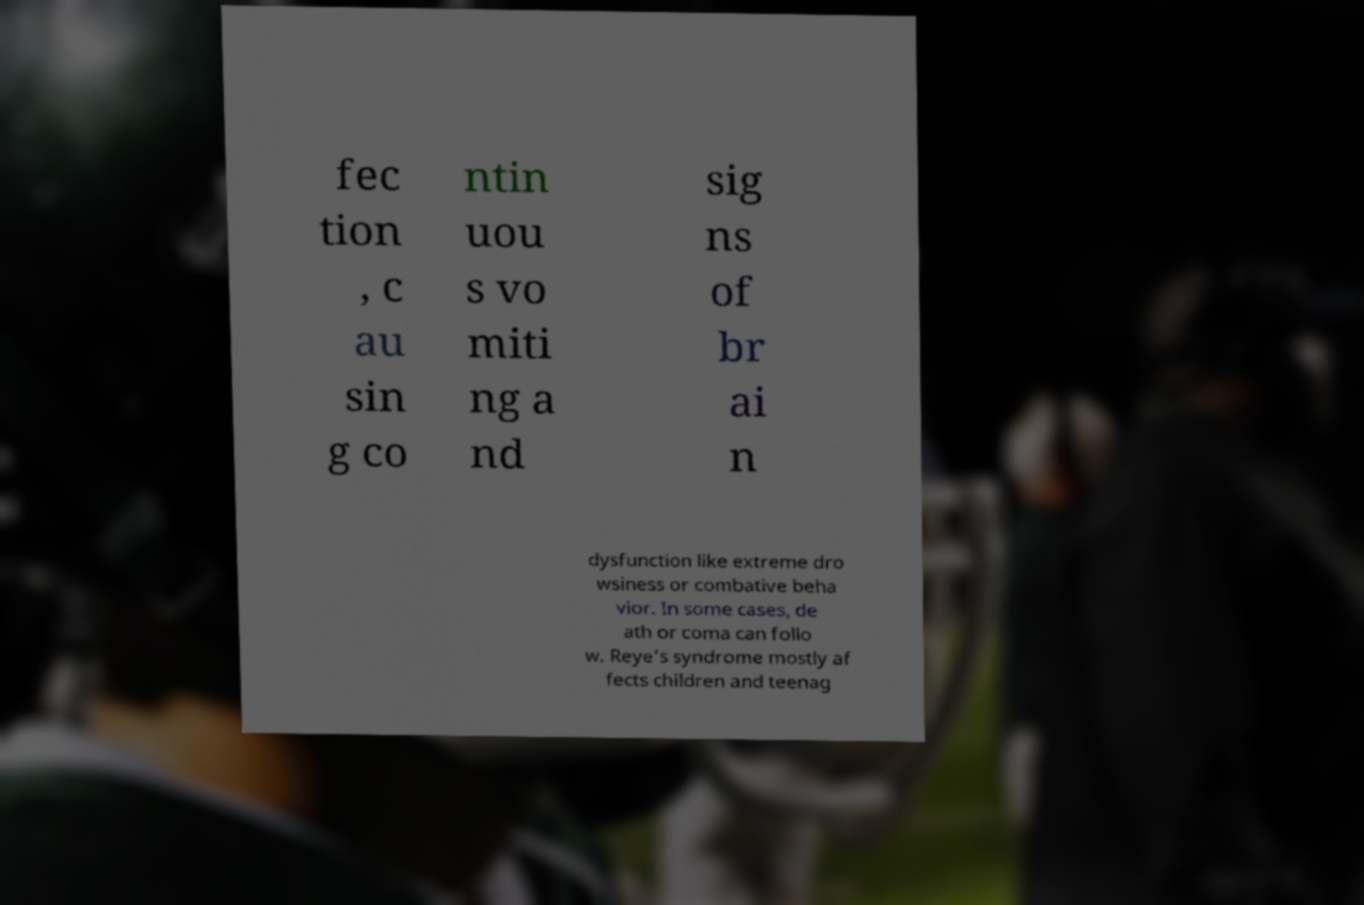Could you assist in decoding the text presented in this image and type it out clearly? fec tion , c au sin g co ntin uou s vo miti ng a nd sig ns of br ai n dysfunction like extreme dro wsiness or combative beha vior. In some cases, de ath or coma can follo w. Reye’s syndrome mostly af fects children and teenag 